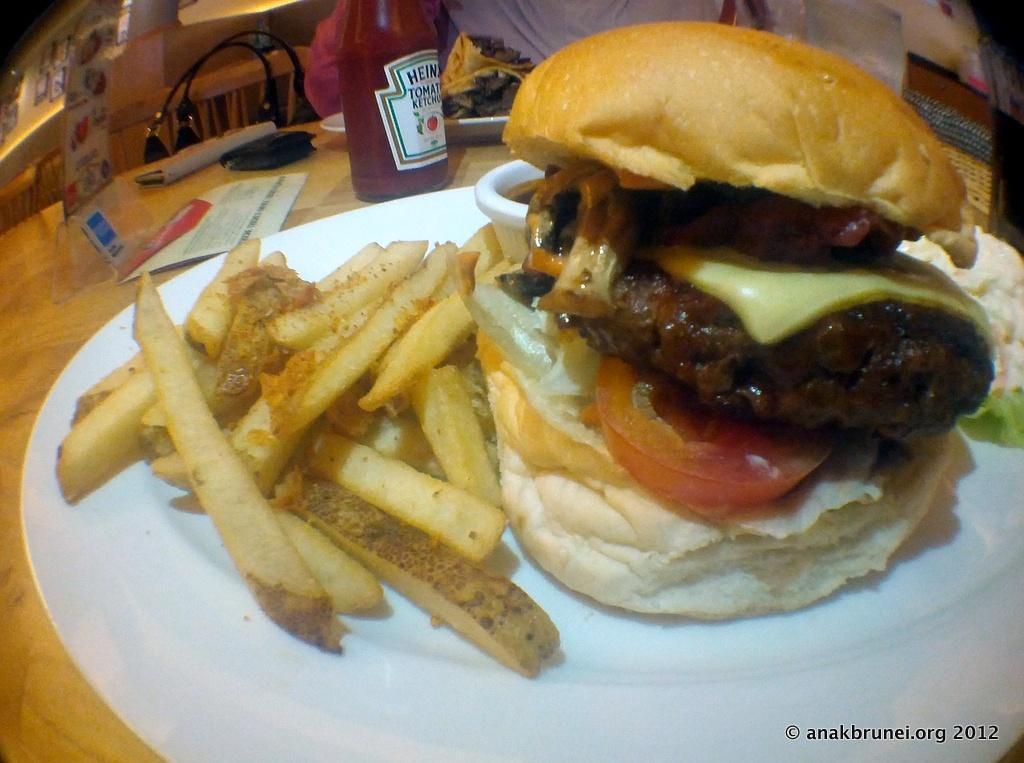How would you summarize this image in a sentence or two? In this image, we can see a plate contains french fries and burger. There is a bottle on the table. 